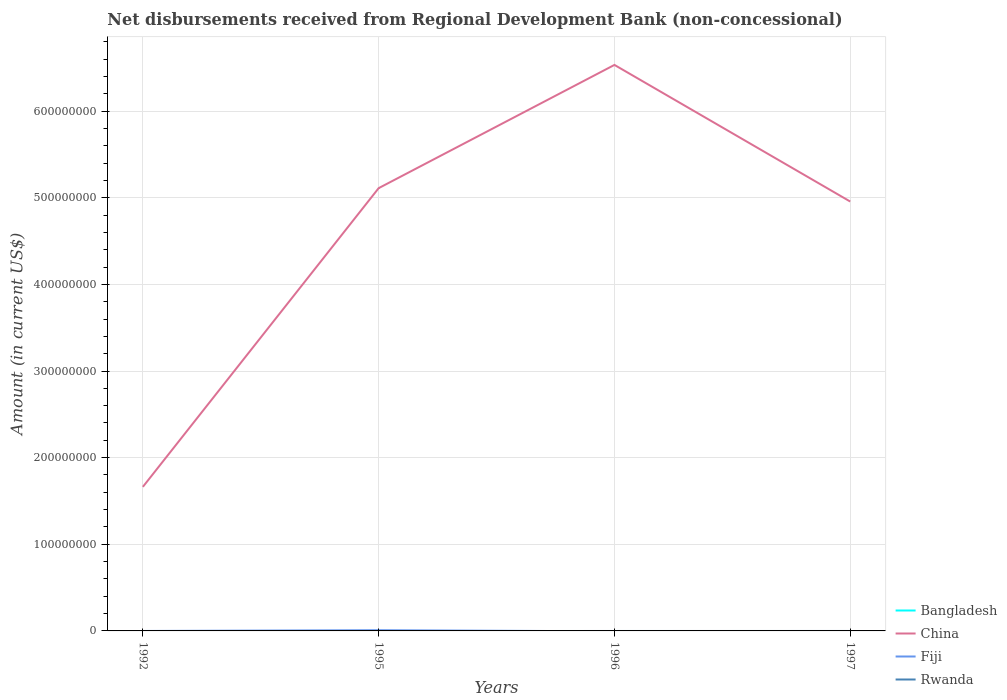How many different coloured lines are there?
Provide a succinct answer. 2. Does the line corresponding to Fiji intersect with the line corresponding to Bangladesh?
Offer a very short reply. Yes. Across all years, what is the maximum amount of disbursements received from Regional Development Bank in Bangladesh?
Offer a terse response. 0. What is the total amount of disbursements received from Regional Development Bank in China in the graph?
Offer a terse response. -3.45e+08. What is the difference between the highest and the second highest amount of disbursements received from Regional Development Bank in China?
Your answer should be very brief. 4.87e+08. Is the amount of disbursements received from Regional Development Bank in Fiji strictly greater than the amount of disbursements received from Regional Development Bank in China over the years?
Offer a terse response. Yes. How many lines are there?
Ensure brevity in your answer.  2. Are the values on the major ticks of Y-axis written in scientific E-notation?
Offer a very short reply. No. Does the graph contain any zero values?
Provide a short and direct response. Yes. Does the graph contain grids?
Offer a terse response. Yes. What is the title of the graph?
Provide a succinct answer. Net disbursements received from Regional Development Bank (non-concessional). What is the Amount (in current US$) of China in 1992?
Your answer should be compact. 1.66e+08. What is the Amount (in current US$) of Rwanda in 1992?
Offer a very short reply. 0. What is the Amount (in current US$) in China in 1995?
Provide a short and direct response. 5.11e+08. What is the Amount (in current US$) in Fiji in 1995?
Make the answer very short. 8.55e+05. What is the Amount (in current US$) of China in 1996?
Make the answer very short. 6.53e+08. What is the Amount (in current US$) of Fiji in 1996?
Your answer should be compact. 0. What is the Amount (in current US$) of Rwanda in 1996?
Make the answer very short. 0. What is the Amount (in current US$) in China in 1997?
Offer a very short reply. 4.96e+08. What is the Amount (in current US$) in Rwanda in 1997?
Give a very brief answer. 0. Across all years, what is the maximum Amount (in current US$) in China?
Your answer should be very brief. 6.53e+08. Across all years, what is the maximum Amount (in current US$) in Fiji?
Your response must be concise. 8.55e+05. Across all years, what is the minimum Amount (in current US$) in China?
Offer a terse response. 1.66e+08. What is the total Amount (in current US$) in China in the graph?
Provide a succinct answer. 1.83e+09. What is the total Amount (in current US$) of Fiji in the graph?
Provide a short and direct response. 8.55e+05. What is the difference between the Amount (in current US$) of China in 1992 and that in 1995?
Your response must be concise. -3.45e+08. What is the difference between the Amount (in current US$) of China in 1992 and that in 1996?
Provide a short and direct response. -4.87e+08. What is the difference between the Amount (in current US$) in China in 1992 and that in 1997?
Make the answer very short. -3.29e+08. What is the difference between the Amount (in current US$) in China in 1995 and that in 1996?
Provide a short and direct response. -1.42e+08. What is the difference between the Amount (in current US$) of China in 1995 and that in 1997?
Offer a very short reply. 1.55e+07. What is the difference between the Amount (in current US$) in China in 1996 and that in 1997?
Offer a very short reply. 1.58e+08. What is the difference between the Amount (in current US$) in China in 1992 and the Amount (in current US$) in Fiji in 1995?
Keep it short and to the point. 1.65e+08. What is the average Amount (in current US$) of Bangladesh per year?
Ensure brevity in your answer.  0. What is the average Amount (in current US$) of China per year?
Provide a succinct answer. 4.57e+08. What is the average Amount (in current US$) of Fiji per year?
Give a very brief answer. 2.14e+05. In the year 1995, what is the difference between the Amount (in current US$) in China and Amount (in current US$) in Fiji?
Your answer should be very brief. 5.10e+08. What is the ratio of the Amount (in current US$) in China in 1992 to that in 1995?
Make the answer very short. 0.33. What is the ratio of the Amount (in current US$) of China in 1992 to that in 1996?
Provide a succinct answer. 0.25. What is the ratio of the Amount (in current US$) in China in 1992 to that in 1997?
Provide a short and direct response. 0.34. What is the ratio of the Amount (in current US$) in China in 1995 to that in 1996?
Offer a very short reply. 0.78. What is the ratio of the Amount (in current US$) in China in 1995 to that in 1997?
Ensure brevity in your answer.  1.03. What is the ratio of the Amount (in current US$) in China in 1996 to that in 1997?
Keep it short and to the point. 1.32. What is the difference between the highest and the second highest Amount (in current US$) in China?
Ensure brevity in your answer.  1.42e+08. What is the difference between the highest and the lowest Amount (in current US$) of China?
Give a very brief answer. 4.87e+08. What is the difference between the highest and the lowest Amount (in current US$) in Fiji?
Keep it short and to the point. 8.55e+05. 